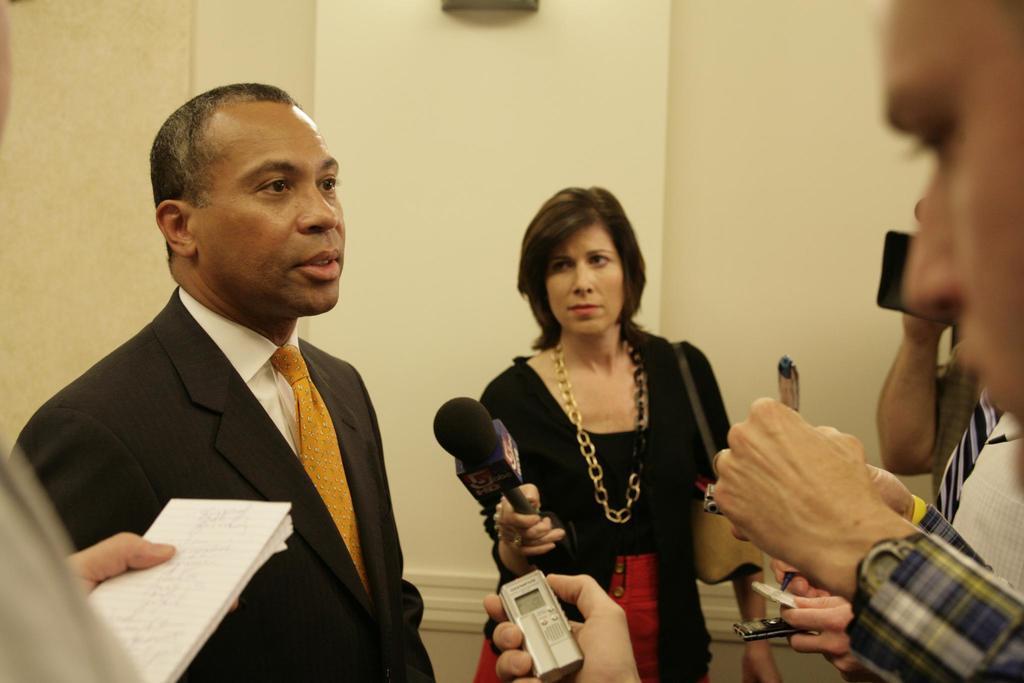How would you summarize this image in a sentence or two? this picture shows a man speaking and a woman holding a microphone in her hand and we see a person holding a book and a man holding a audio recorder in his hand and we see a man holding a camera and recording 